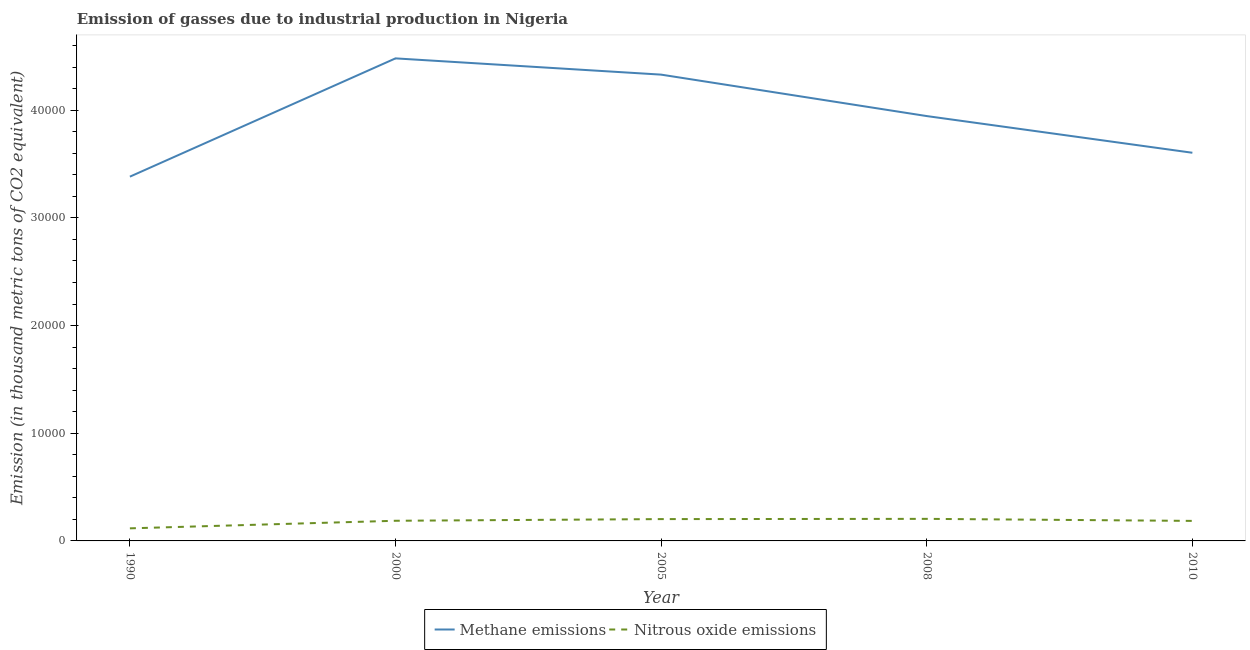Does the line corresponding to amount of methane emissions intersect with the line corresponding to amount of nitrous oxide emissions?
Keep it short and to the point. No. What is the amount of methane emissions in 2008?
Keep it short and to the point. 3.95e+04. Across all years, what is the maximum amount of methane emissions?
Give a very brief answer. 4.48e+04. Across all years, what is the minimum amount of nitrous oxide emissions?
Your answer should be compact. 1168.8. In which year was the amount of methane emissions maximum?
Provide a succinct answer. 2000. In which year was the amount of methane emissions minimum?
Give a very brief answer. 1990. What is the total amount of nitrous oxide emissions in the graph?
Make the answer very short. 8977.8. What is the difference between the amount of methane emissions in 1990 and that in 2008?
Ensure brevity in your answer.  -5627.2. What is the difference between the amount of methane emissions in 1990 and the amount of nitrous oxide emissions in 2000?
Keep it short and to the point. 3.20e+04. What is the average amount of methane emissions per year?
Give a very brief answer. 3.95e+04. In the year 2008, what is the difference between the amount of methane emissions and amount of nitrous oxide emissions?
Offer a very short reply. 3.74e+04. In how many years, is the amount of methane emissions greater than 22000 thousand metric tons?
Provide a short and direct response. 5. What is the ratio of the amount of nitrous oxide emissions in 2008 to that in 2010?
Offer a very short reply. 1.1. Is the amount of nitrous oxide emissions in 2000 less than that in 2005?
Provide a succinct answer. Yes. What is the difference between the highest and the second highest amount of nitrous oxide emissions?
Provide a succinct answer. 22. What is the difference between the highest and the lowest amount of nitrous oxide emissions?
Offer a very short reply. 880.5. In how many years, is the amount of methane emissions greater than the average amount of methane emissions taken over all years?
Keep it short and to the point. 2. Is the amount of nitrous oxide emissions strictly less than the amount of methane emissions over the years?
Your answer should be compact. Yes. Does the graph contain any zero values?
Keep it short and to the point. No. How many legend labels are there?
Provide a succinct answer. 2. How are the legend labels stacked?
Give a very brief answer. Horizontal. What is the title of the graph?
Provide a short and direct response. Emission of gasses due to industrial production in Nigeria. What is the label or title of the X-axis?
Give a very brief answer. Year. What is the label or title of the Y-axis?
Keep it short and to the point. Emission (in thousand metric tons of CO2 equivalent). What is the Emission (in thousand metric tons of CO2 equivalent) in Methane emissions in 1990?
Make the answer very short. 3.38e+04. What is the Emission (in thousand metric tons of CO2 equivalent) in Nitrous oxide emissions in 1990?
Make the answer very short. 1168.8. What is the Emission (in thousand metric tons of CO2 equivalent) in Methane emissions in 2000?
Your answer should be very brief. 4.48e+04. What is the Emission (in thousand metric tons of CO2 equivalent) in Nitrous oxide emissions in 2000?
Provide a short and direct response. 1872.4. What is the Emission (in thousand metric tons of CO2 equivalent) of Methane emissions in 2005?
Your answer should be compact. 4.33e+04. What is the Emission (in thousand metric tons of CO2 equivalent) in Nitrous oxide emissions in 2005?
Give a very brief answer. 2027.3. What is the Emission (in thousand metric tons of CO2 equivalent) of Methane emissions in 2008?
Your response must be concise. 3.95e+04. What is the Emission (in thousand metric tons of CO2 equivalent) in Nitrous oxide emissions in 2008?
Provide a short and direct response. 2049.3. What is the Emission (in thousand metric tons of CO2 equivalent) of Methane emissions in 2010?
Your answer should be very brief. 3.61e+04. What is the Emission (in thousand metric tons of CO2 equivalent) of Nitrous oxide emissions in 2010?
Ensure brevity in your answer.  1860. Across all years, what is the maximum Emission (in thousand metric tons of CO2 equivalent) in Methane emissions?
Give a very brief answer. 4.48e+04. Across all years, what is the maximum Emission (in thousand metric tons of CO2 equivalent) of Nitrous oxide emissions?
Give a very brief answer. 2049.3. Across all years, what is the minimum Emission (in thousand metric tons of CO2 equivalent) of Methane emissions?
Ensure brevity in your answer.  3.38e+04. Across all years, what is the minimum Emission (in thousand metric tons of CO2 equivalent) in Nitrous oxide emissions?
Keep it short and to the point. 1168.8. What is the total Emission (in thousand metric tons of CO2 equivalent) in Methane emissions in the graph?
Your answer should be compact. 1.97e+05. What is the total Emission (in thousand metric tons of CO2 equivalent) in Nitrous oxide emissions in the graph?
Ensure brevity in your answer.  8977.8. What is the difference between the Emission (in thousand metric tons of CO2 equivalent) in Methane emissions in 1990 and that in 2000?
Give a very brief answer. -1.10e+04. What is the difference between the Emission (in thousand metric tons of CO2 equivalent) in Nitrous oxide emissions in 1990 and that in 2000?
Your response must be concise. -703.6. What is the difference between the Emission (in thousand metric tons of CO2 equivalent) of Methane emissions in 1990 and that in 2005?
Your answer should be compact. -9476.4. What is the difference between the Emission (in thousand metric tons of CO2 equivalent) in Nitrous oxide emissions in 1990 and that in 2005?
Make the answer very short. -858.5. What is the difference between the Emission (in thousand metric tons of CO2 equivalent) in Methane emissions in 1990 and that in 2008?
Your answer should be very brief. -5627.2. What is the difference between the Emission (in thousand metric tons of CO2 equivalent) in Nitrous oxide emissions in 1990 and that in 2008?
Provide a short and direct response. -880.5. What is the difference between the Emission (in thousand metric tons of CO2 equivalent) in Methane emissions in 1990 and that in 2010?
Offer a terse response. -2220. What is the difference between the Emission (in thousand metric tons of CO2 equivalent) of Nitrous oxide emissions in 1990 and that in 2010?
Your answer should be very brief. -691.2. What is the difference between the Emission (in thousand metric tons of CO2 equivalent) of Methane emissions in 2000 and that in 2005?
Give a very brief answer. 1509.9. What is the difference between the Emission (in thousand metric tons of CO2 equivalent) of Nitrous oxide emissions in 2000 and that in 2005?
Your answer should be compact. -154.9. What is the difference between the Emission (in thousand metric tons of CO2 equivalent) in Methane emissions in 2000 and that in 2008?
Ensure brevity in your answer.  5359.1. What is the difference between the Emission (in thousand metric tons of CO2 equivalent) in Nitrous oxide emissions in 2000 and that in 2008?
Your answer should be compact. -176.9. What is the difference between the Emission (in thousand metric tons of CO2 equivalent) in Methane emissions in 2000 and that in 2010?
Provide a succinct answer. 8766.3. What is the difference between the Emission (in thousand metric tons of CO2 equivalent) in Nitrous oxide emissions in 2000 and that in 2010?
Offer a very short reply. 12.4. What is the difference between the Emission (in thousand metric tons of CO2 equivalent) of Methane emissions in 2005 and that in 2008?
Make the answer very short. 3849.2. What is the difference between the Emission (in thousand metric tons of CO2 equivalent) in Methane emissions in 2005 and that in 2010?
Your answer should be compact. 7256.4. What is the difference between the Emission (in thousand metric tons of CO2 equivalent) of Nitrous oxide emissions in 2005 and that in 2010?
Keep it short and to the point. 167.3. What is the difference between the Emission (in thousand metric tons of CO2 equivalent) of Methane emissions in 2008 and that in 2010?
Keep it short and to the point. 3407.2. What is the difference between the Emission (in thousand metric tons of CO2 equivalent) of Nitrous oxide emissions in 2008 and that in 2010?
Offer a very short reply. 189.3. What is the difference between the Emission (in thousand metric tons of CO2 equivalent) in Methane emissions in 1990 and the Emission (in thousand metric tons of CO2 equivalent) in Nitrous oxide emissions in 2000?
Your answer should be very brief. 3.20e+04. What is the difference between the Emission (in thousand metric tons of CO2 equivalent) in Methane emissions in 1990 and the Emission (in thousand metric tons of CO2 equivalent) in Nitrous oxide emissions in 2005?
Your response must be concise. 3.18e+04. What is the difference between the Emission (in thousand metric tons of CO2 equivalent) in Methane emissions in 1990 and the Emission (in thousand metric tons of CO2 equivalent) in Nitrous oxide emissions in 2008?
Your response must be concise. 3.18e+04. What is the difference between the Emission (in thousand metric tons of CO2 equivalent) in Methane emissions in 1990 and the Emission (in thousand metric tons of CO2 equivalent) in Nitrous oxide emissions in 2010?
Provide a short and direct response. 3.20e+04. What is the difference between the Emission (in thousand metric tons of CO2 equivalent) in Methane emissions in 2000 and the Emission (in thousand metric tons of CO2 equivalent) in Nitrous oxide emissions in 2005?
Your answer should be compact. 4.28e+04. What is the difference between the Emission (in thousand metric tons of CO2 equivalent) of Methane emissions in 2000 and the Emission (in thousand metric tons of CO2 equivalent) of Nitrous oxide emissions in 2008?
Offer a very short reply. 4.28e+04. What is the difference between the Emission (in thousand metric tons of CO2 equivalent) in Methane emissions in 2000 and the Emission (in thousand metric tons of CO2 equivalent) in Nitrous oxide emissions in 2010?
Your response must be concise. 4.30e+04. What is the difference between the Emission (in thousand metric tons of CO2 equivalent) of Methane emissions in 2005 and the Emission (in thousand metric tons of CO2 equivalent) of Nitrous oxide emissions in 2008?
Provide a succinct answer. 4.13e+04. What is the difference between the Emission (in thousand metric tons of CO2 equivalent) of Methane emissions in 2005 and the Emission (in thousand metric tons of CO2 equivalent) of Nitrous oxide emissions in 2010?
Give a very brief answer. 4.14e+04. What is the difference between the Emission (in thousand metric tons of CO2 equivalent) of Methane emissions in 2008 and the Emission (in thousand metric tons of CO2 equivalent) of Nitrous oxide emissions in 2010?
Your response must be concise. 3.76e+04. What is the average Emission (in thousand metric tons of CO2 equivalent) in Methane emissions per year?
Provide a succinct answer. 3.95e+04. What is the average Emission (in thousand metric tons of CO2 equivalent) in Nitrous oxide emissions per year?
Your answer should be very brief. 1795.56. In the year 1990, what is the difference between the Emission (in thousand metric tons of CO2 equivalent) in Methane emissions and Emission (in thousand metric tons of CO2 equivalent) in Nitrous oxide emissions?
Ensure brevity in your answer.  3.27e+04. In the year 2000, what is the difference between the Emission (in thousand metric tons of CO2 equivalent) of Methane emissions and Emission (in thousand metric tons of CO2 equivalent) of Nitrous oxide emissions?
Offer a very short reply. 4.29e+04. In the year 2005, what is the difference between the Emission (in thousand metric tons of CO2 equivalent) of Methane emissions and Emission (in thousand metric tons of CO2 equivalent) of Nitrous oxide emissions?
Your answer should be compact. 4.13e+04. In the year 2008, what is the difference between the Emission (in thousand metric tons of CO2 equivalent) of Methane emissions and Emission (in thousand metric tons of CO2 equivalent) of Nitrous oxide emissions?
Make the answer very short. 3.74e+04. In the year 2010, what is the difference between the Emission (in thousand metric tons of CO2 equivalent) of Methane emissions and Emission (in thousand metric tons of CO2 equivalent) of Nitrous oxide emissions?
Offer a terse response. 3.42e+04. What is the ratio of the Emission (in thousand metric tons of CO2 equivalent) of Methane emissions in 1990 to that in 2000?
Your answer should be very brief. 0.75. What is the ratio of the Emission (in thousand metric tons of CO2 equivalent) in Nitrous oxide emissions in 1990 to that in 2000?
Provide a succinct answer. 0.62. What is the ratio of the Emission (in thousand metric tons of CO2 equivalent) of Methane emissions in 1990 to that in 2005?
Your answer should be very brief. 0.78. What is the ratio of the Emission (in thousand metric tons of CO2 equivalent) of Nitrous oxide emissions in 1990 to that in 2005?
Give a very brief answer. 0.58. What is the ratio of the Emission (in thousand metric tons of CO2 equivalent) of Methane emissions in 1990 to that in 2008?
Provide a succinct answer. 0.86. What is the ratio of the Emission (in thousand metric tons of CO2 equivalent) in Nitrous oxide emissions in 1990 to that in 2008?
Offer a terse response. 0.57. What is the ratio of the Emission (in thousand metric tons of CO2 equivalent) of Methane emissions in 1990 to that in 2010?
Give a very brief answer. 0.94. What is the ratio of the Emission (in thousand metric tons of CO2 equivalent) in Nitrous oxide emissions in 1990 to that in 2010?
Provide a short and direct response. 0.63. What is the ratio of the Emission (in thousand metric tons of CO2 equivalent) in Methane emissions in 2000 to that in 2005?
Provide a succinct answer. 1.03. What is the ratio of the Emission (in thousand metric tons of CO2 equivalent) of Nitrous oxide emissions in 2000 to that in 2005?
Your response must be concise. 0.92. What is the ratio of the Emission (in thousand metric tons of CO2 equivalent) of Methane emissions in 2000 to that in 2008?
Your answer should be compact. 1.14. What is the ratio of the Emission (in thousand metric tons of CO2 equivalent) of Nitrous oxide emissions in 2000 to that in 2008?
Provide a succinct answer. 0.91. What is the ratio of the Emission (in thousand metric tons of CO2 equivalent) in Methane emissions in 2000 to that in 2010?
Keep it short and to the point. 1.24. What is the ratio of the Emission (in thousand metric tons of CO2 equivalent) in Methane emissions in 2005 to that in 2008?
Offer a very short reply. 1.1. What is the ratio of the Emission (in thousand metric tons of CO2 equivalent) in Nitrous oxide emissions in 2005 to that in 2008?
Ensure brevity in your answer.  0.99. What is the ratio of the Emission (in thousand metric tons of CO2 equivalent) of Methane emissions in 2005 to that in 2010?
Make the answer very short. 1.2. What is the ratio of the Emission (in thousand metric tons of CO2 equivalent) in Nitrous oxide emissions in 2005 to that in 2010?
Your answer should be compact. 1.09. What is the ratio of the Emission (in thousand metric tons of CO2 equivalent) of Methane emissions in 2008 to that in 2010?
Offer a terse response. 1.09. What is the ratio of the Emission (in thousand metric tons of CO2 equivalent) in Nitrous oxide emissions in 2008 to that in 2010?
Keep it short and to the point. 1.1. What is the difference between the highest and the second highest Emission (in thousand metric tons of CO2 equivalent) in Methane emissions?
Your answer should be compact. 1509.9. What is the difference between the highest and the second highest Emission (in thousand metric tons of CO2 equivalent) of Nitrous oxide emissions?
Your answer should be very brief. 22. What is the difference between the highest and the lowest Emission (in thousand metric tons of CO2 equivalent) of Methane emissions?
Offer a very short reply. 1.10e+04. What is the difference between the highest and the lowest Emission (in thousand metric tons of CO2 equivalent) in Nitrous oxide emissions?
Ensure brevity in your answer.  880.5. 